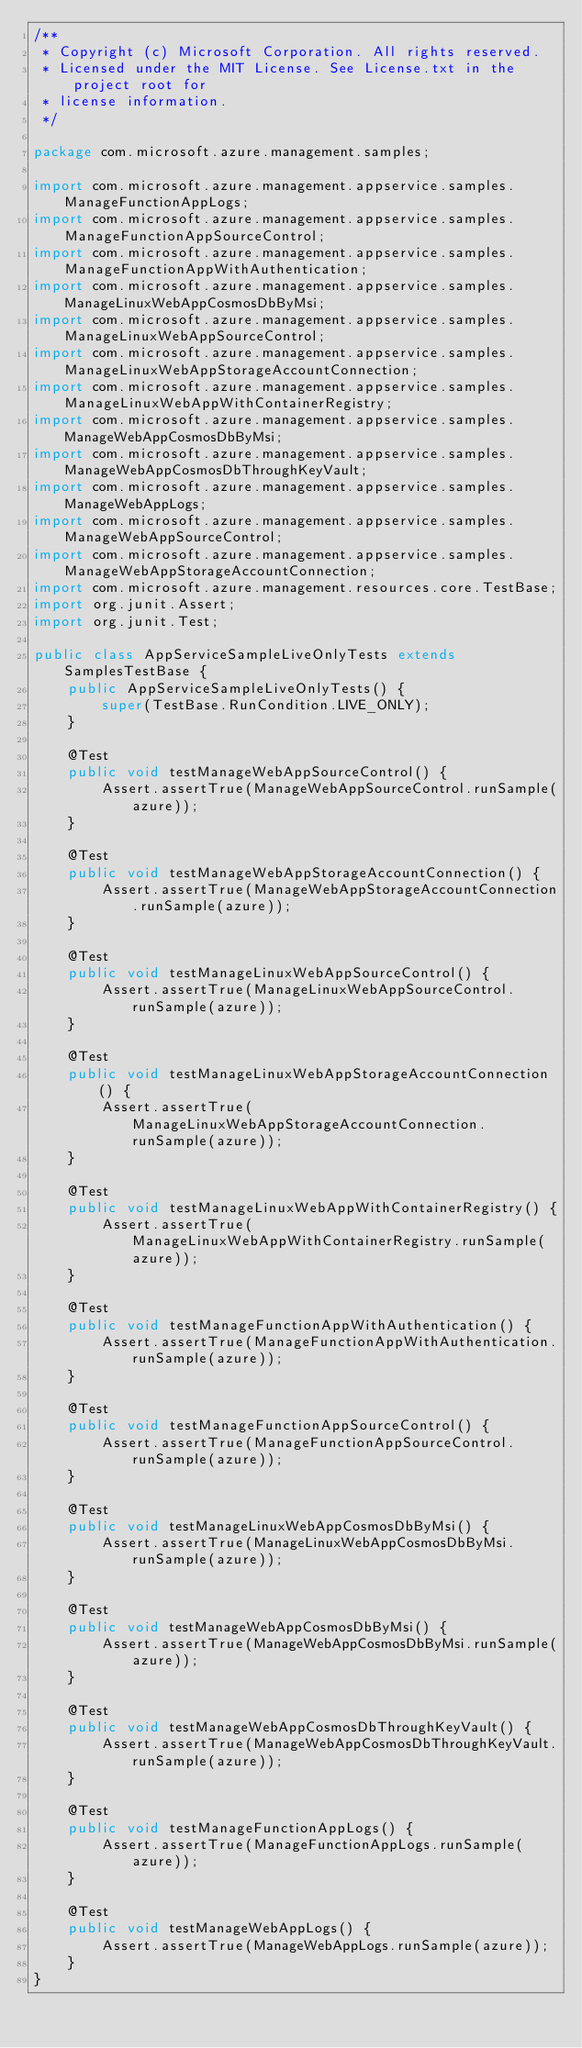<code> <loc_0><loc_0><loc_500><loc_500><_Java_>/**
 * Copyright (c) Microsoft Corporation. All rights reserved.
 * Licensed under the MIT License. See License.txt in the project root for
 * license information.
 */

package com.microsoft.azure.management.samples;

import com.microsoft.azure.management.appservice.samples.ManageFunctionAppLogs;
import com.microsoft.azure.management.appservice.samples.ManageFunctionAppSourceControl;
import com.microsoft.azure.management.appservice.samples.ManageFunctionAppWithAuthentication;
import com.microsoft.azure.management.appservice.samples.ManageLinuxWebAppCosmosDbByMsi;
import com.microsoft.azure.management.appservice.samples.ManageLinuxWebAppSourceControl;
import com.microsoft.azure.management.appservice.samples.ManageLinuxWebAppStorageAccountConnection;
import com.microsoft.azure.management.appservice.samples.ManageLinuxWebAppWithContainerRegistry;
import com.microsoft.azure.management.appservice.samples.ManageWebAppCosmosDbByMsi;
import com.microsoft.azure.management.appservice.samples.ManageWebAppCosmosDbThroughKeyVault;
import com.microsoft.azure.management.appservice.samples.ManageWebAppLogs;
import com.microsoft.azure.management.appservice.samples.ManageWebAppSourceControl;
import com.microsoft.azure.management.appservice.samples.ManageWebAppStorageAccountConnection;
import com.microsoft.azure.management.resources.core.TestBase;
import org.junit.Assert;
import org.junit.Test;

public class AppServiceSampleLiveOnlyTests extends SamplesTestBase {
    public AppServiceSampleLiveOnlyTests() {
        super(TestBase.RunCondition.LIVE_ONLY);
    }

    @Test
    public void testManageWebAppSourceControl() {
        Assert.assertTrue(ManageWebAppSourceControl.runSample(azure));
    }

    @Test
    public void testManageWebAppStorageAccountConnection() {
        Assert.assertTrue(ManageWebAppStorageAccountConnection.runSample(azure));
    }

    @Test
    public void testManageLinuxWebAppSourceControl() {
        Assert.assertTrue(ManageLinuxWebAppSourceControl.runSample(azure));
    }

    @Test
    public void testManageLinuxWebAppStorageAccountConnection() {
        Assert.assertTrue(ManageLinuxWebAppStorageAccountConnection.runSample(azure));
    }

    @Test
    public void testManageLinuxWebAppWithContainerRegistry() {
        Assert.assertTrue(ManageLinuxWebAppWithContainerRegistry.runSample(azure));
    }

    @Test
    public void testManageFunctionAppWithAuthentication() {
        Assert.assertTrue(ManageFunctionAppWithAuthentication.runSample(azure));
    }

    @Test
    public void testManageFunctionAppSourceControl() {
        Assert.assertTrue(ManageFunctionAppSourceControl.runSample(azure));
    }

    @Test
    public void testManageLinuxWebAppCosmosDbByMsi() {
        Assert.assertTrue(ManageLinuxWebAppCosmosDbByMsi.runSample(azure));
    }

    @Test
    public void testManageWebAppCosmosDbByMsi() {
        Assert.assertTrue(ManageWebAppCosmosDbByMsi.runSample(azure));
    }

    @Test
    public void testManageWebAppCosmosDbThroughKeyVault() {
        Assert.assertTrue(ManageWebAppCosmosDbThroughKeyVault.runSample(azure));
    }

    @Test
    public void testManageFunctionAppLogs() {
        Assert.assertTrue(ManageFunctionAppLogs.runSample(azure));
    }

    @Test
    public void testManageWebAppLogs() {
        Assert.assertTrue(ManageWebAppLogs.runSample(azure));
    }
}
</code> 